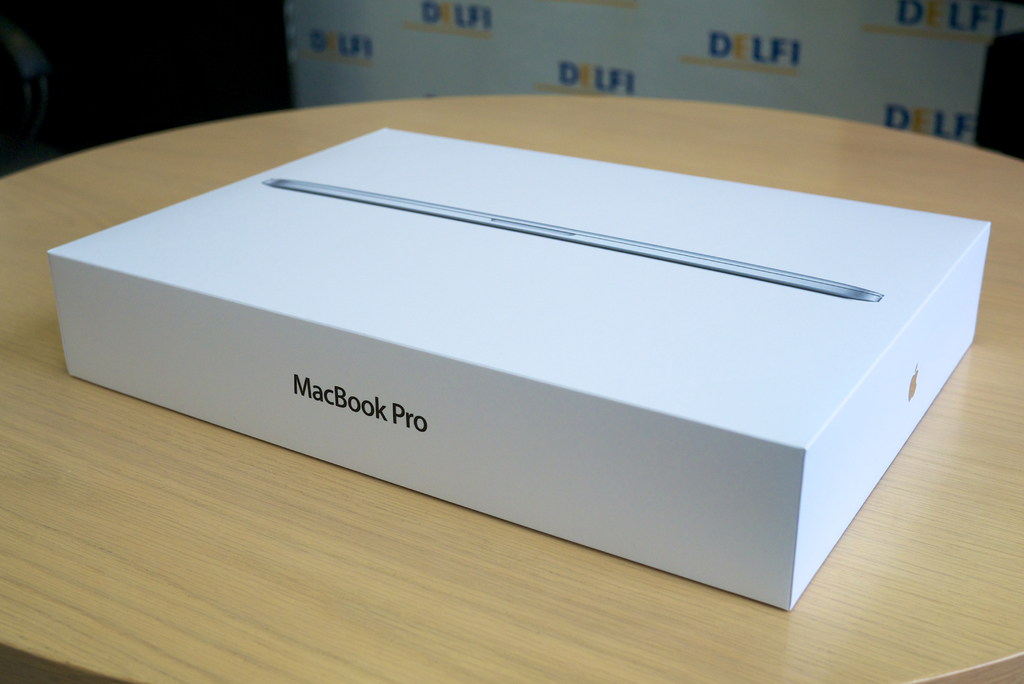What are the key elements in this picture? The image prominently features a sealed white box of a MacBook Pro on a wooden table, indicating the product’s pristine condition. The box itself displays the laptop’s image on the top along with the product’s name, emphasizing its brand identity. The surrounding area, a deli-style setting with 'DELI' decor, contrasts with the modern tech product, suggesting a blend of traditional and modern elements in this setup. This juxtaposition can be reflective of the product's appeal to a trendy, urban demographic. 